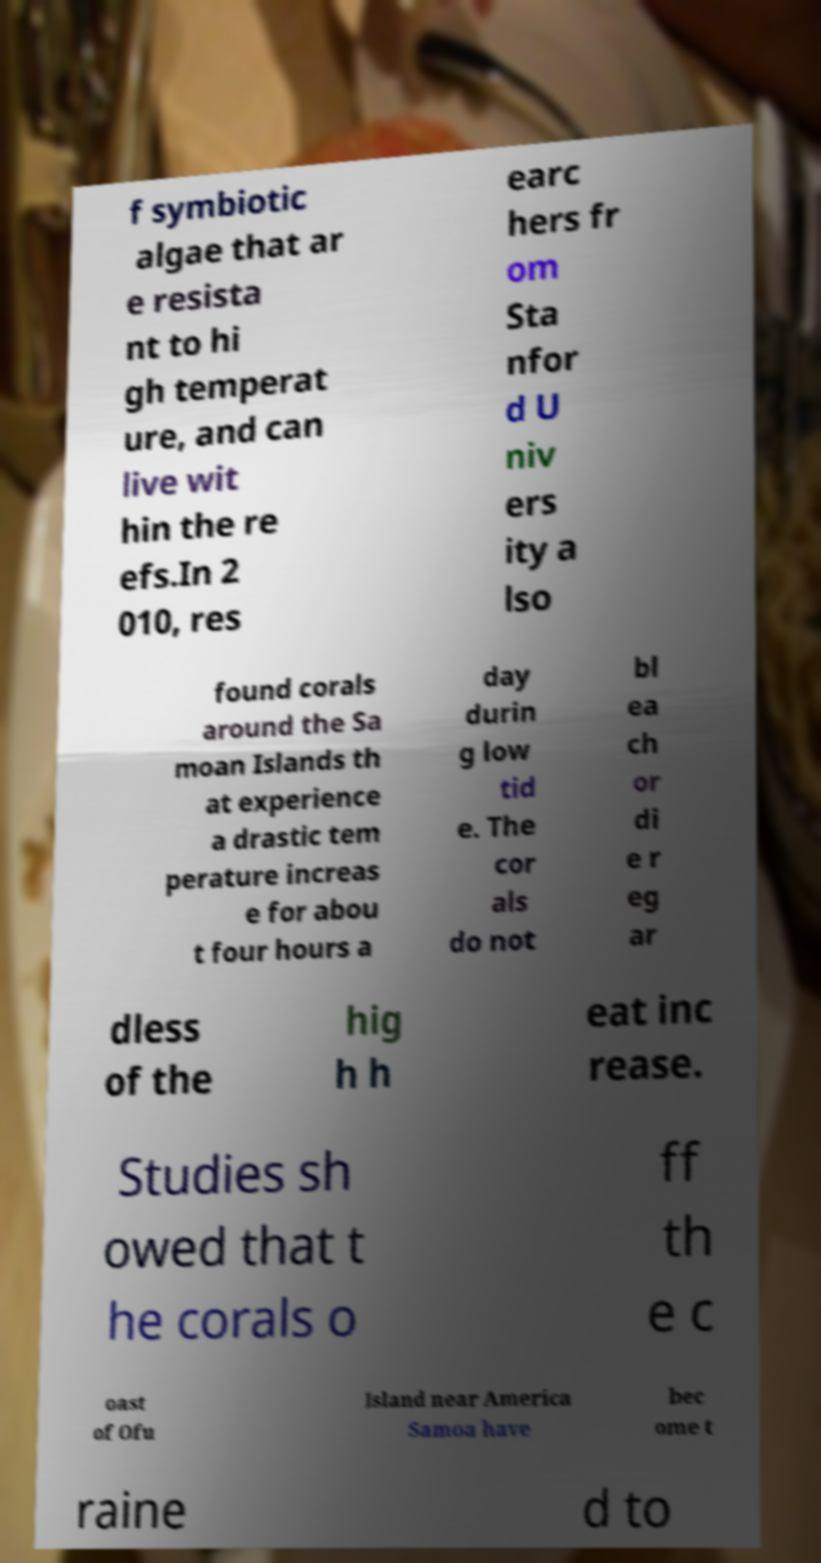There's text embedded in this image that I need extracted. Can you transcribe it verbatim? f symbiotic algae that ar e resista nt to hi gh temperat ure, and can live wit hin the re efs.In 2 010, res earc hers fr om Sta nfor d U niv ers ity a lso found corals around the Sa moan Islands th at experience a drastic tem perature increas e for abou t four hours a day durin g low tid e. The cor als do not bl ea ch or di e r eg ar dless of the hig h h eat inc rease. Studies sh owed that t he corals o ff th e c oast of Ofu Island near America Samoa have bec ome t raine d to 